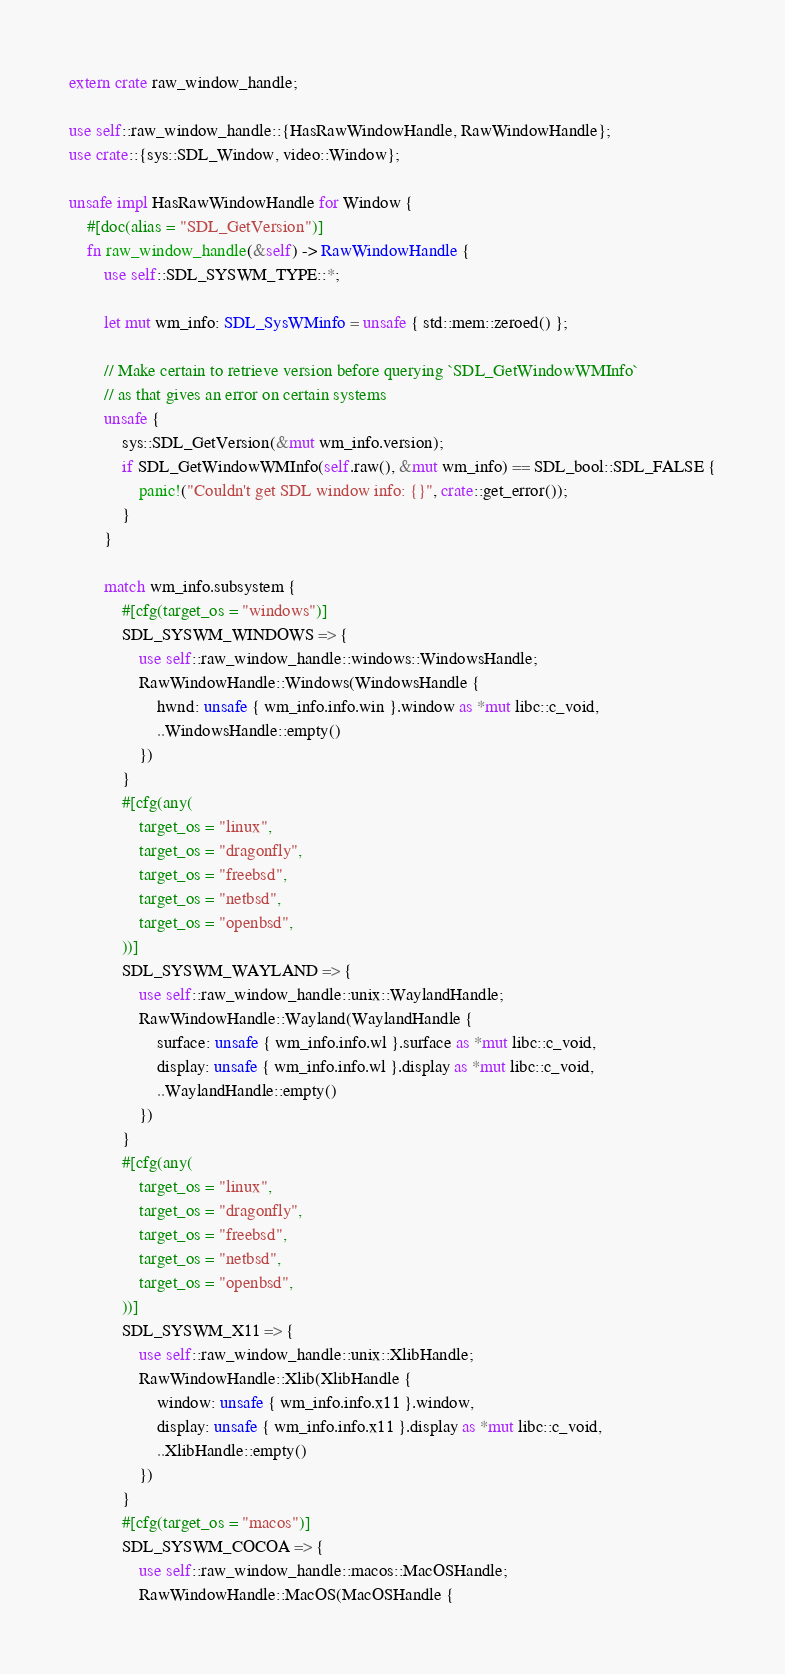Convert code to text. <code><loc_0><loc_0><loc_500><loc_500><_Rust_>extern crate raw_window_handle;

use self::raw_window_handle::{HasRawWindowHandle, RawWindowHandle};
use crate::{sys::SDL_Window, video::Window};

unsafe impl HasRawWindowHandle for Window {
    #[doc(alias = "SDL_GetVersion")]
    fn raw_window_handle(&self) -> RawWindowHandle {
        use self::SDL_SYSWM_TYPE::*;

        let mut wm_info: SDL_SysWMinfo = unsafe { std::mem::zeroed() };

        // Make certain to retrieve version before querying `SDL_GetWindowWMInfo`
        // as that gives an error on certain systems
        unsafe {
            sys::SDL_GetVersion(&mut wm_info.version);
            if SDL_GetWindowWMInfo(self.raw(), &mut wm_info) == SDL_bool::SDL_FALSE {
                panic!("Couldn't get SDL window info: {}", crate::get_error());
            }
        }

        match wm_info.subsystem {
            #[cfg(target_os = "windows")]
            SDL_SYSWM_WINDOWS => {
                use self::raw_window_handle::windows::WindowsHandle;
                RawWindowHandle::Windows(WindowsHandle {
                    hwnd: unsafe { wm_info.info.win }.window as *mut libc::c_void,
                    ..WindowsHandle::empty()
                })
            }
            #[cfg(any(
                target_os = "linux",
                target_os = "dragonfly",
                target_os = "freebsd",
                target_os = "netbsd",
                target_os = "openbsd",
            ))]
            SDL_SYSWM_WAYLAND => {
                use self::raw_window_handle::unix::WaylandHandle;
                RawWindowHandle::Wayland(WaylandHandle {
                    surface: unsafe { wm_info.info.wl }.surface as *mut libc::c_void,
                    display: unsafe { wm_info.info.wl }.display as *mut libc::c_void,
                    ..WaylandHandle::empty()
                })
            }
            #[cfg(any(
                target_os = "linux",
                target_os = "dragonfly",
                target_os = "freebsd",
                target_os = "netbsd",
                target_os = "openbsd",
            ))]
            SDL_SYSWM_X11 => {
                use self::raw_window_handle::unix::XlibHandle;
                RawWindowHandle::Xlib(XlibHandle {
                    window: unsafe { wm_info.info.x11 }.window,
                    display: unsafe { wm_info.info.x11 }.display as *mut libc::c_void,
                    ..XlibHandle::empty()
                })
            }
            #[cfg(target_os = "macos")]
            SDL_SYSWM_COCOA => {
                use self::raw_window_handle::macos::MacOSHandle;
                RawWindowHandle::MacOS(MacOSHandle {</code> 